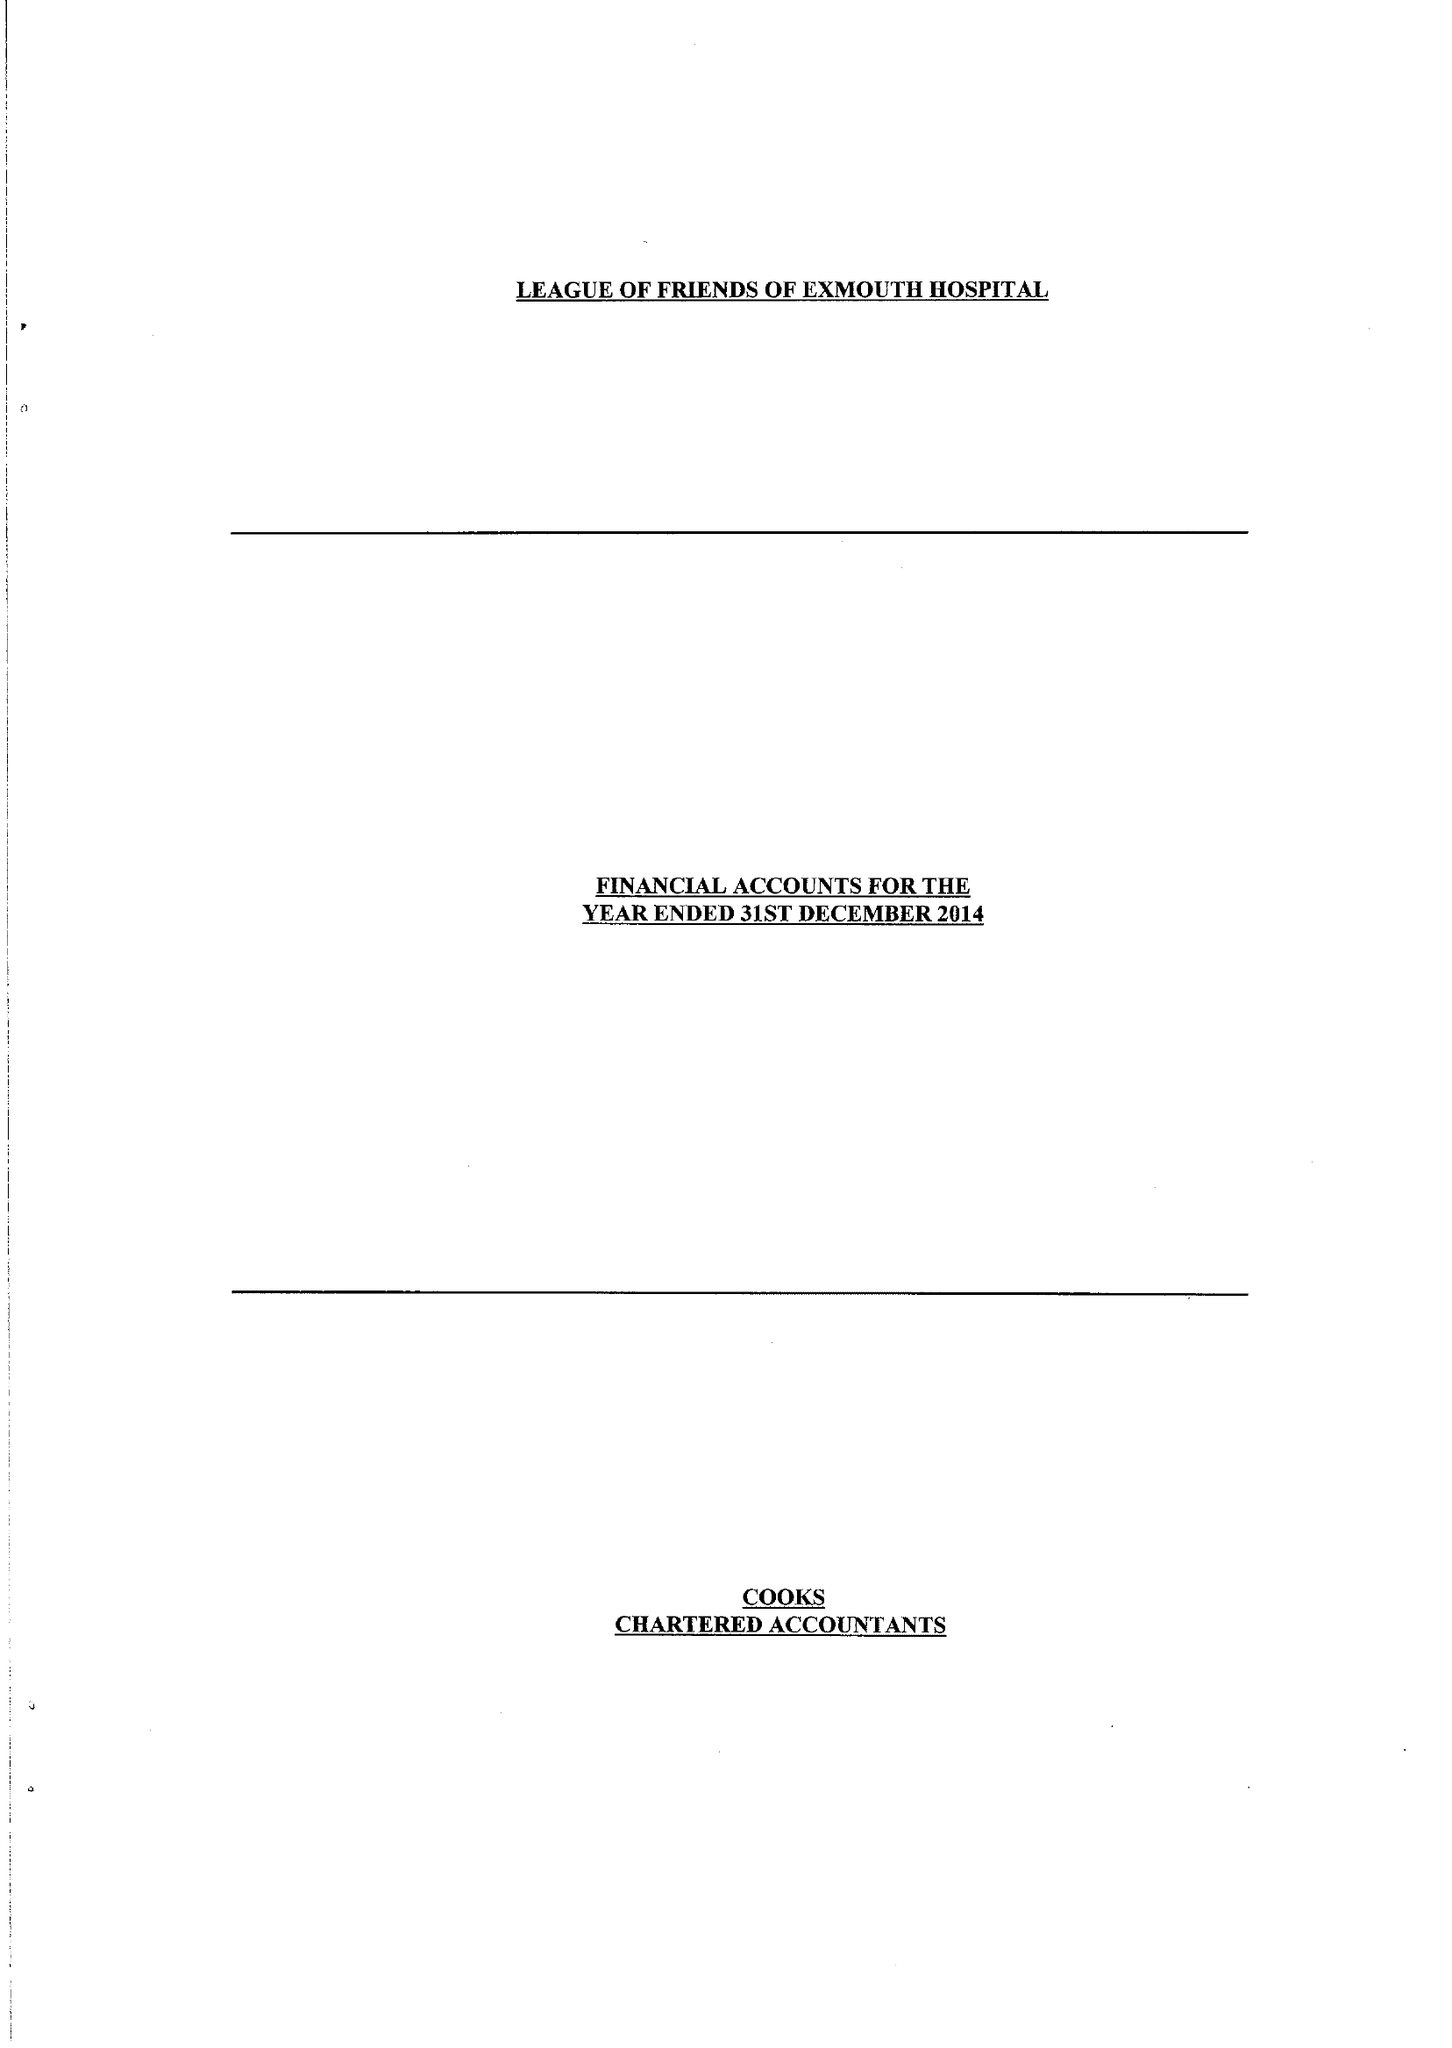What is the value for the income_annually_in_british_pounds?
Answer the question using a single word or phrase. 43559.00 